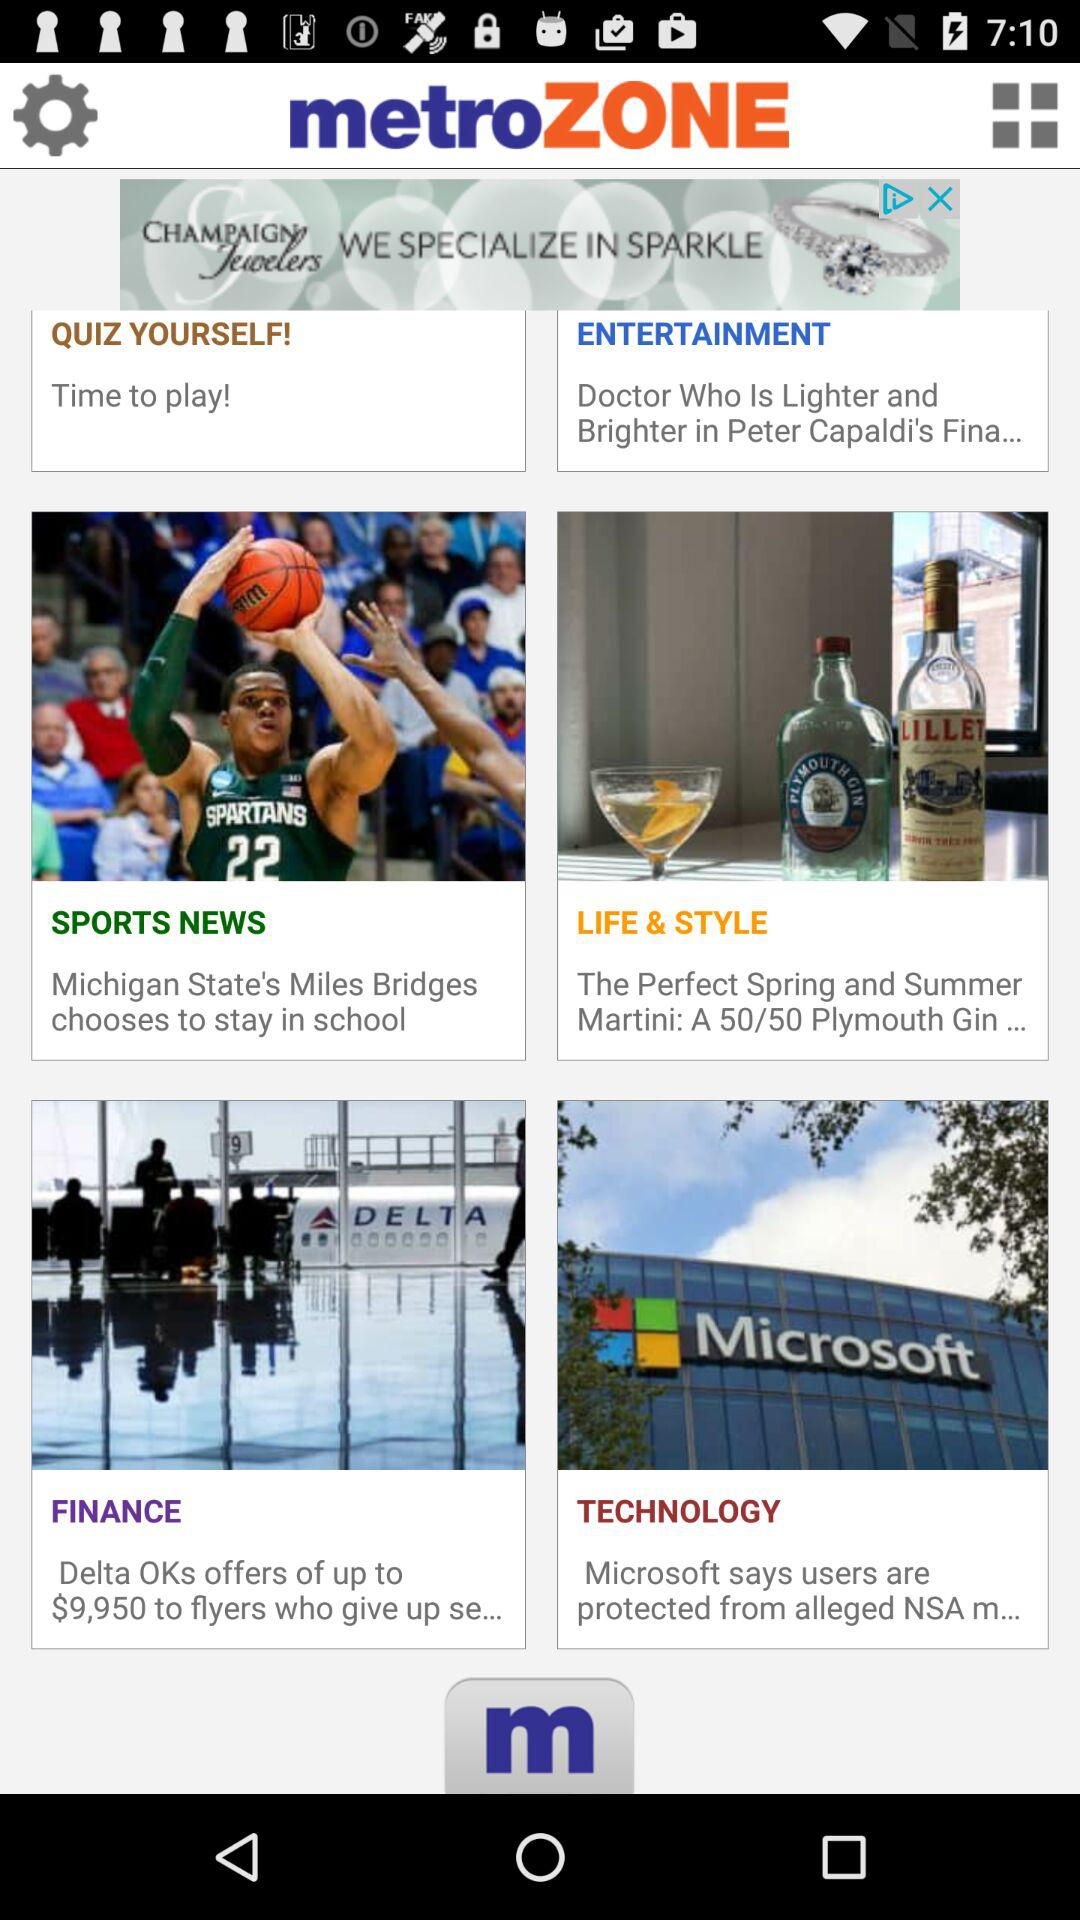What is the name of the application? The name of the application is "metroZONE". 